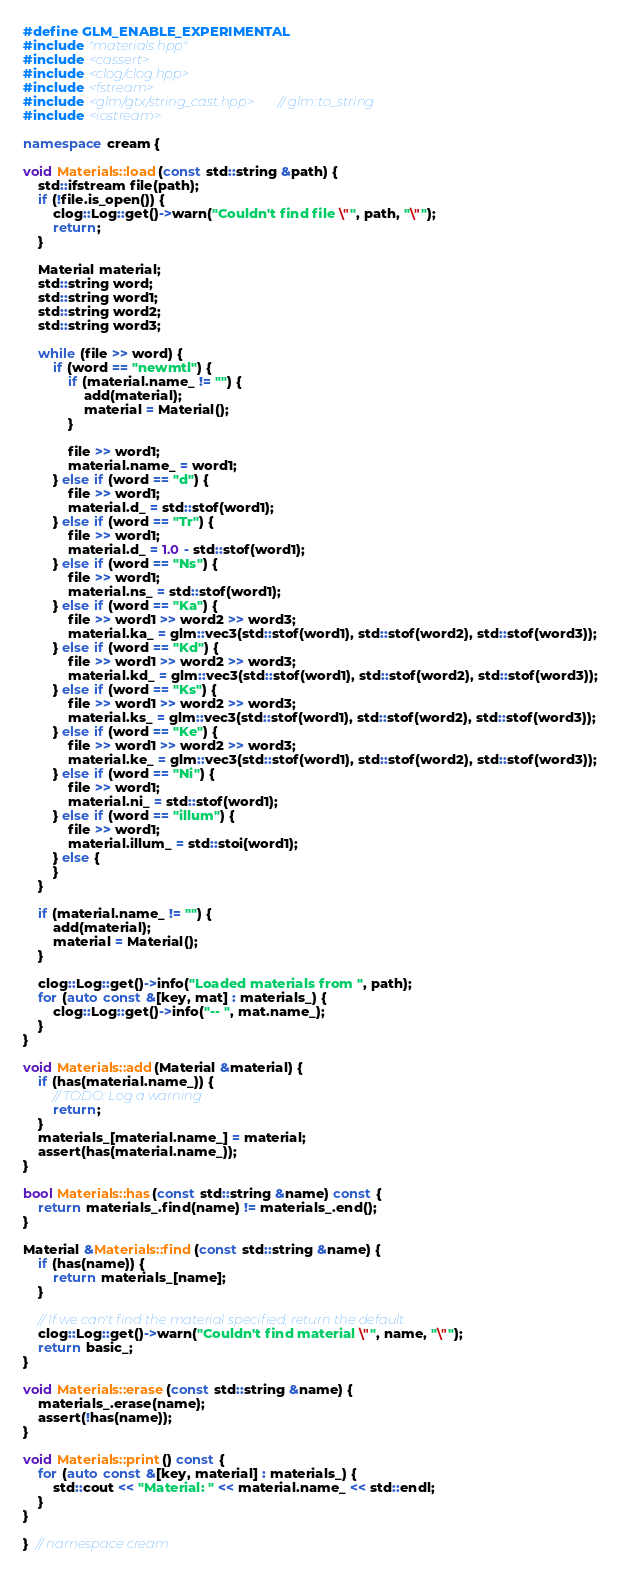Convert code to text. <code><loc_0><loc_0><loc_500><loc_500><_C++_>#define GLM_ENABLE_EXPERIMENTAL
#include "materials.hpp"
#include <cassert>
#include <clog/clog.hpp>
#include <fstream>
#include <glm/gtx/string_cast.hpp>  // glm::to_string
#include <iostream>

namespace cream {

void Materials::load(const std::string &path) {
    std::ifstream file(path);
    if (!file.is_open()) {
        clog::Log::get()->warn("Couldn't find file \"", path, "\"");
        return;
    }

    Material material;
    std::string word;
    std::string word1;
    std::string word2;
    std::string word3;

    while (file >> word) {
        if (word == "newmtl") {
            if (material.name_ != "") {
                add(material);
                material = Material();
            }

            file >> word1;
            material.name_ = word1;
        } else if (word == "d") {
            file >> word1;
            material.d_ = std::stof(word1);
        } else if (word == "Tr") {
            file >> word1;
            material.d_ = 1.0 - std::stof(word1);
        } else if (word == "Ns") {
            file >> word1;
            material.ns_ = std::stof(word1);
        } else if (word == "Ka") {
            file >> word1 >> word2 >> word3;
            material.ka_ = glm::vec3(std::stof(word1), std::stof(word2), std::stof(word3));
        } else if (word == "Kd") {
            file >> word1 >> word2 >> word3;
            material.kd_ = glm::vec3(std::stof(word1), std::stof(word2), std::stof(word3));
        } else if (word == "Ks") {
            file >> word1 >> word2 >> word3;
            material.ks_ = glm::vec3(std::stof(word1), std::stof(word2), std::stof(word3));
        } else if (word == "Ke") {
            file >> word1 >> word2 >> word3;
            material.ke_ = glm::vec3(std::stof(word1), std::stof(word2), std::stof(word3));
        } else if (word == "Ni") {
            file >> word1;
            material.ni_ = std::stof(word1);
        } else if (word == "illum") {
            file >> word1;
            material.illum_ = std::stoi(word1);
        } else {
        }
    }

    if (material.name_ != "") {
        add(material);
        material = Material();
    }

    clog::Log::get()->info("Loaded materials from ", path);
    for (auto const &[key, mat] : materials_) {
        clog::Log::get()->info("-- ", mat.name_);
    }
}

void Materials::add(Material &material) {
    if (has(material.name_)) {
        // TODO: Log a warning
        return;
    }
    materials_[material.name_] = material;
    assert(has(material.name_));
}

bool Materials::has(const std::string &name) const {
    return materials_.find(name) != materials_.end();
}

Material &Materials::find(const std::string &name) {
    if (has(name)) {
        return materials_[name];
    }

    // If we can't find the material specified, return the default
    clog::Log::get()->warn("Couldn't find material \"", name, "\"");
    return basic_;
}

void Materials::erase(const std::string &name) {
    materials_.erase(name);
    assert(!has(name));
}

void Materials::print() const {
    for (auto const &[key, material] : materials_) {
        std::cout << "Material: " << material.name_ << std::endl;
    }
}

}  // namespace cream
</code> 